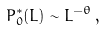Convert formula to latex. <formula><loc_0><loc_0><loc_500><loc_500>P ^ { * } _ { 0 } ( L ) \sim L ^ { - \theta } \, ,</formula> 